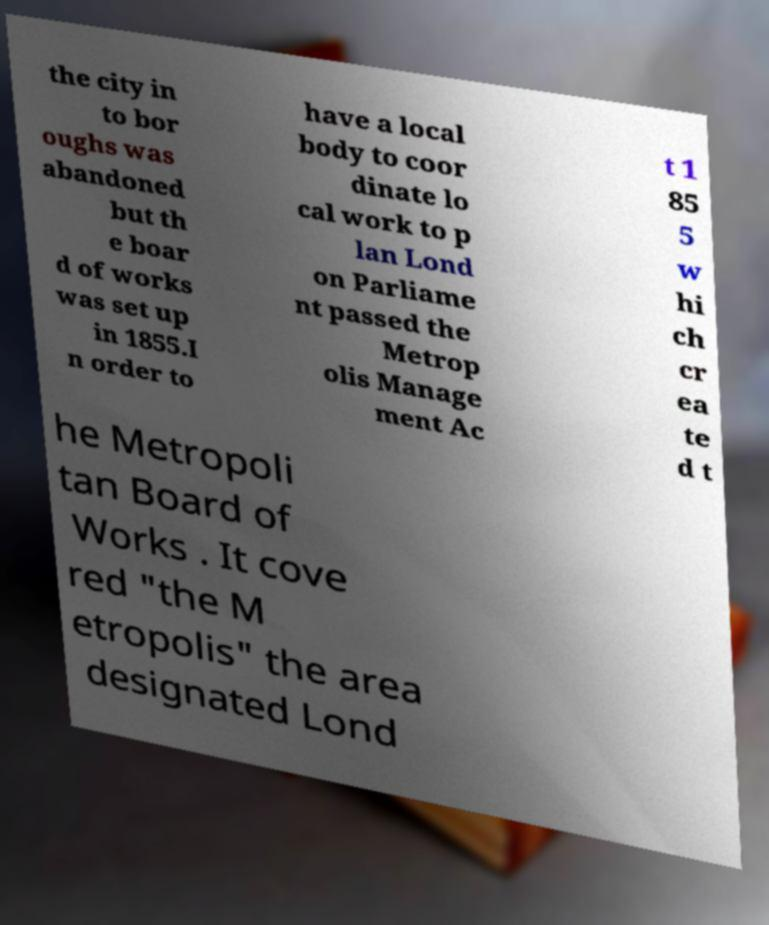Can you read and provide the text displayed in the image?This photo seems to have some interesting text. Can you extract and type it out for me? the city in to bor oughs was abandoned but th e boar d of works was set up in 1855.I n order to have a local body to coor dinate lo cal work to p lan Lond on Parliame nt passed the Metrop olis Manage ment Ac t 1 85 5 w hi ch cr ea te d t he Metropoli tan Board of Works . It cove red "the M etropolis" the area designated Lond 